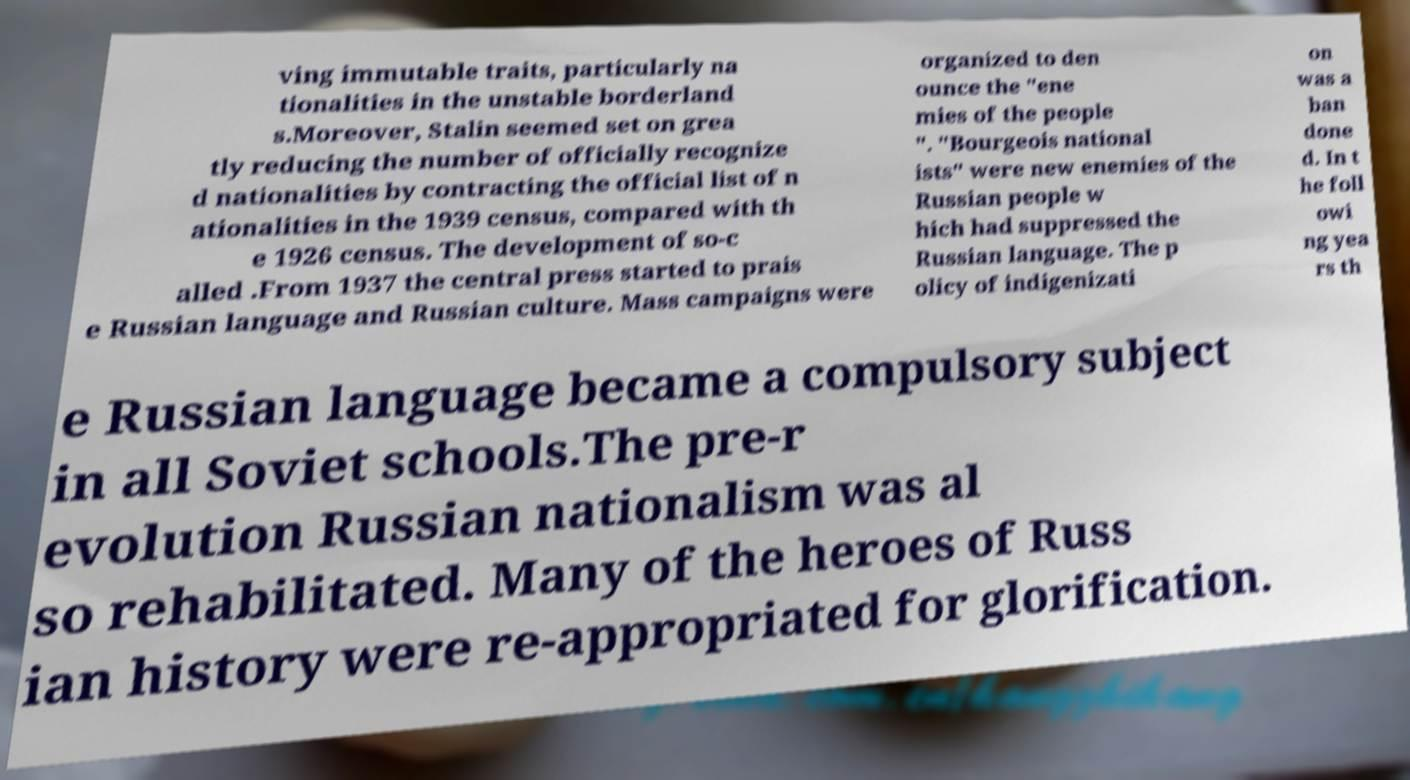I need the written content from this picture converted into text. Can you do that? ving immutable traits, particularly na tionalities in the unstable borderland s.Moreover, Stalin seemed set on grea tly reducing the number of officially recognize d nationalities by contracting the official list of n ationalities in the 1939 census, compared with th e 1926 census. The development of so-c alled .From 1937 the central press started to prais e Russian language and Russian culture. Mass campaigns were organized to den ounce the "ene mies of the people ". "Bourgeois national ists" were new enemies of the Russian people w hich had suppressed the Russian language. The p olicy of indigenizati on was a ban done d. In t he foll owi ng yea rs th e Russian language became a compulsory subject in all Soviet schools.The pre-r evolution Russian nationalism was al so rehabilitated. Many of the heroes of Russ ian history were re-appropriated for glorification. 